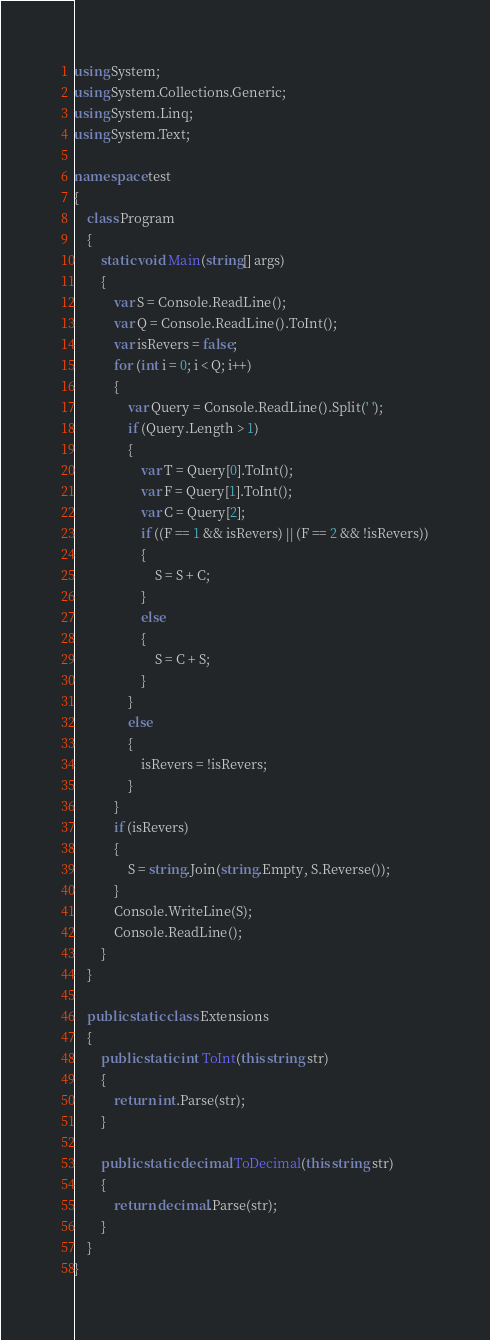Convert code to text. <code><loc_0><loc_0><loc_500><loc_500><_C#_>using System;
using System.Collections.Generic;
using System.Linq;
using System.Text;

namespace test
{
    class Program
    {
        static void Main(string[] args)
        {
            var S = Console.ReadLine();
            var Q = Console.ReadLine().ToInt();
            var isRevers = false;
            for (int i = 0; i < Q; i++)
            {
                var Query = Console.ReadLine().Split(' ');
                if (Query.Length > 1)
                {
                    var T = Query[0].ToInt();
                    var F = Query[1].ToInt();
                    var C = Query[2];
                    if ((F == 1 && isRevers) || (F == 2 && !isRevers))
                    {
                        S = S + C;
                    }
                    else
                    {
                        S = C + S;
                    }
                }
                else
                {
                    isRevers = !isRevers;
                }
            }
            if (isRevers)
            {
                S = string.Join(string.Empty, S.Reverse());
            }
            Console.WriteLine(S);
            Console.ReadLine();
        }
    }

    public static class Extensions
    {
        public static int ToInt(this string str)
        {
            return int.Parse(str);
        }

        public static decimal ToDecimal(this string str)
        {
            return decimal.Parse(str);
        }
    }
}
</code> 